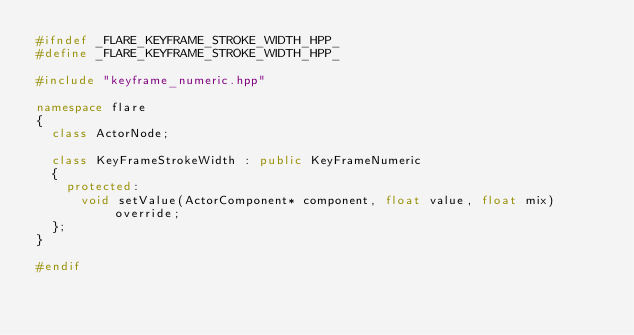<code> <loc_0><loc_0><loc_500><loc_500><_C++_>#ifndef _FLARE_KEYFRAME_STROKE_WIDTH_HPP_
#define _FLARE_KEYFRAME_STROKE_WIDTH_HPP_

#include "keyframe_numeric.hpp"

namespace flare
{
	class ActorNode;

	class KeyFrameStrokeWidth : public KeyFrameNumeric
	{
		protected:
			void setValue(ActorComponent* component, float value, float mix) override;
	};
}

#endif</code> 